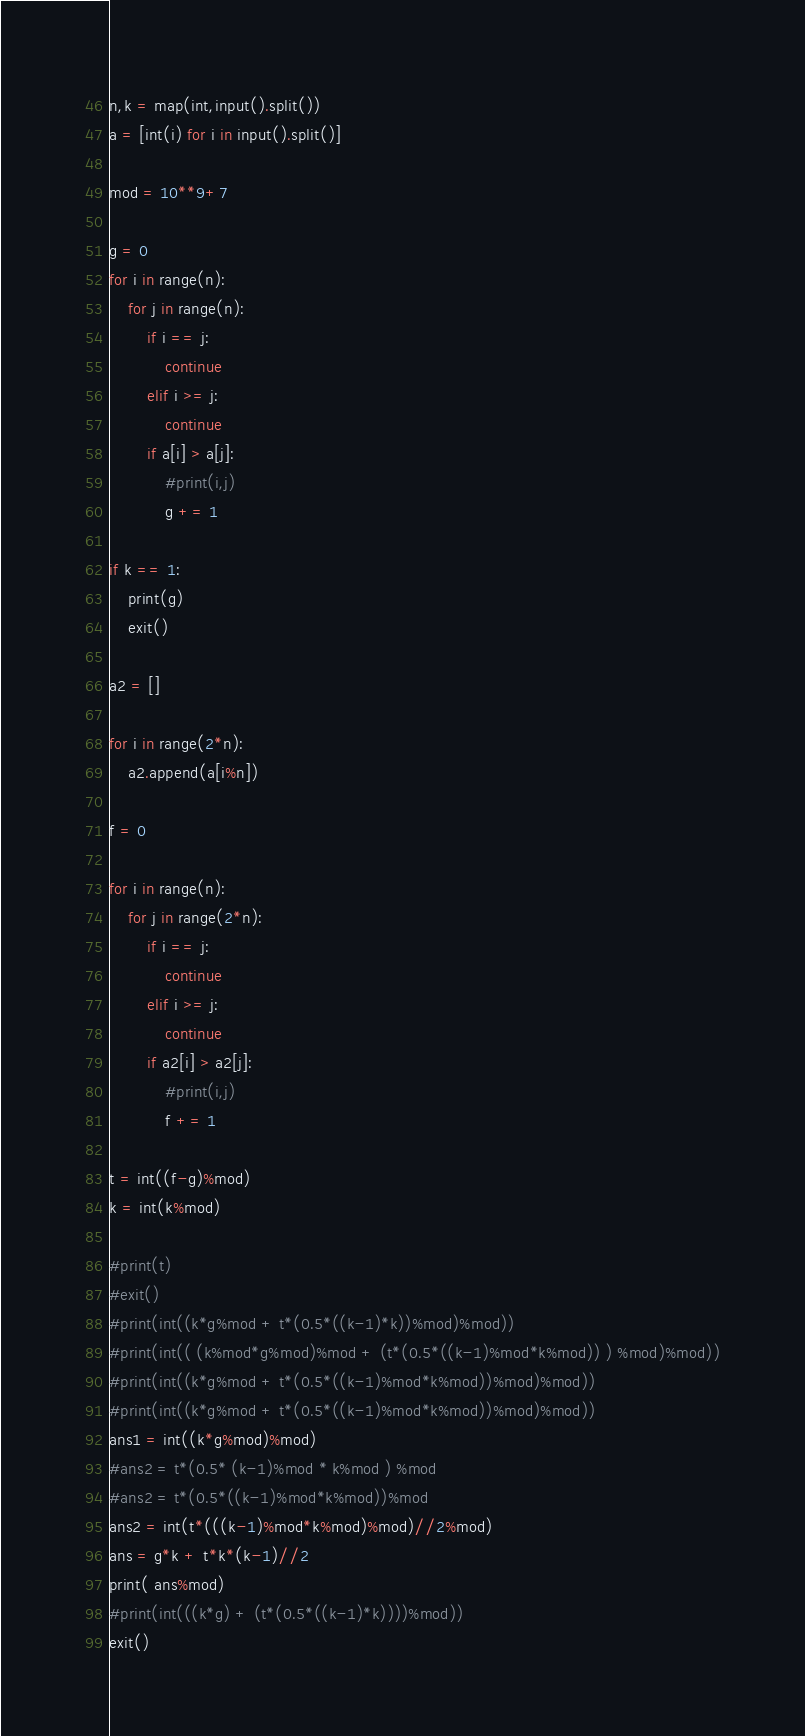<code> <loc_0><loc_0><loc_500><loc_500><_Python_>n,k = map(int,input().split())
a = [int(i) for i in input().split()]

mod = 10**9+7

g = 0
for i in range(n):
    for j in range(n):
        if i == j:
            continue
        elif i >= j:
            continue
        if a[i] > a[j]:
            #print(i,j)
            g += 1

if k == 1:
    print(g)
    exit()
    
a2 = []

for i in range(2*n):
    a2.append(a[i%n])
    
f = 0

for i in range(n):
    for j in range(2*n):
        if i == j:
            continue
        elif i >= j:
            continue
        if a2[i] > a2[j]:
            #print(i,j)
            f += 1

t = int((f-g)%mod)
k = int(k%mod)

#print(t)
#exit()
#print(int((k*g%mod + t*(0.5*((k-1)*k))%mod)%mod))
#print(int(( (k%mod*g%mod)%mod + (t*(0.5*((k-1)%mod*k%mod)) ) %mod)%mod))
#print(int((k*g%mod + t*(0.5*((k-1)%mod*k%mod))%mod)%mod))
#print(int((k*g%mod + t*(0.5*((k-1)%mod*k%mod))%mod)%mod))
ans1 = int((k*g%mod)%mod)
#ans2 = t*(0.5* (k-1)%mod * k%mod ) %mod
#ans2 = t*(0.5*((k-1)%mod*k%mod))%mod
ans2 = int(t*(((k-1)%mod*k%mod)%mod)//2%mod)
ans = g*k + t*k*(k-1)//2
print( ans%mod)
#print(int(((k*g) + (t*(0.5*((k-1)*k))))%mod))
exit()

</code> 